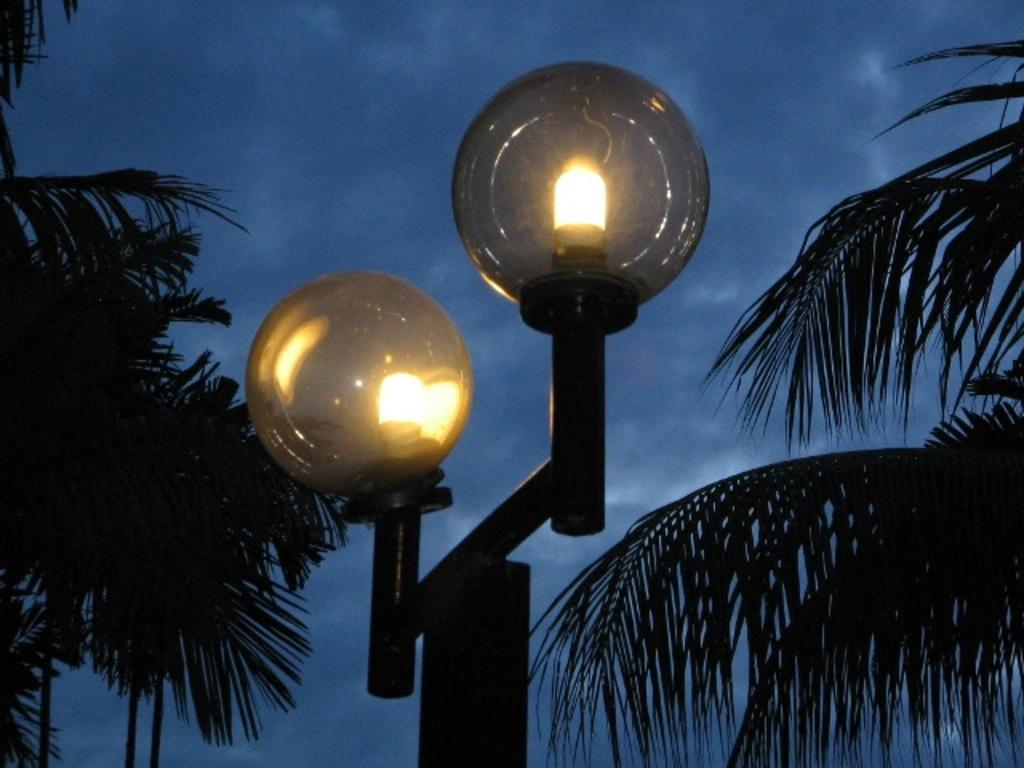What type of vegetation can be seen in the image? There are trees in the image. What is attached to the pole in the image? The pole has lights attached to it. What is visible in the background of the image? The sky is visible in the image. What can be seen in the sky in the image? Clouds are present in the sky. What brand of toothpaste is advertised on the pole in the image? There is no toothpaste or advertisement present on the pole in the image; it only has lights attached to it. What type of beef dish is being prepared in the image? There is no beef dish or any food preparation visible in the image. 